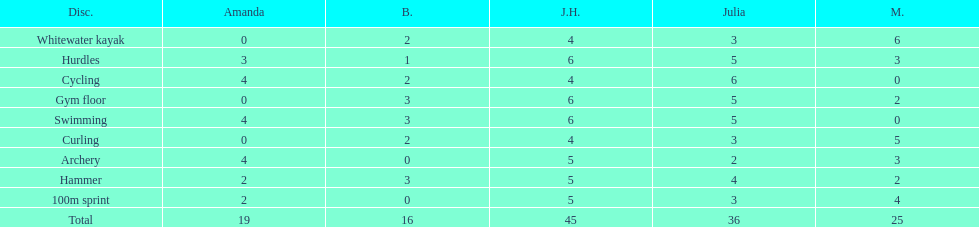What are the number of points bernie scored in hurdles? 1. 